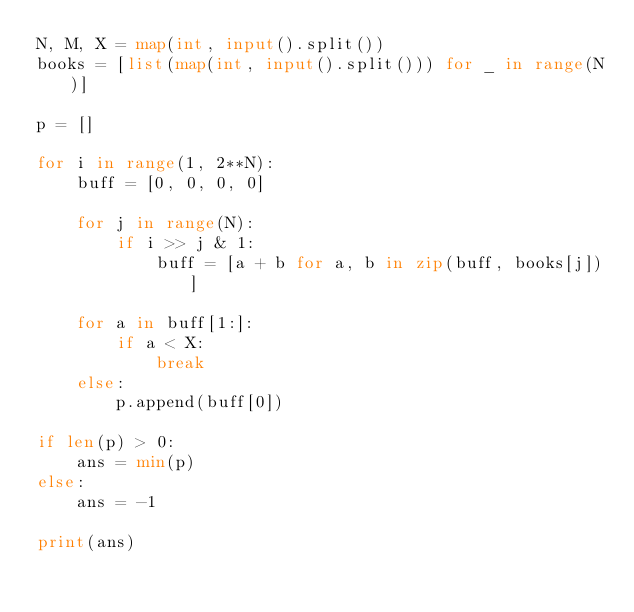Convert code to text. <code><loc_0><loc_0><loc_500><loc_500><_Python_>N, M, X = map(int, input().split())
books = [list(map(int, input().split())) for _ in range(N)]

p = []

for i in range(1, 2**N):
    buff = [0, 0, 0, 0]

    for j in range(N):
        if i >> j & 1:
            buff = [a + b for a, b in zip(buff, books[j])]

    for a in buff[1:]:
        if a < X:
            break
    else:
        p.append(buff[0])

if len(p) > 0:
    ans = min(p)
else:
    ans = -1

print(ans)
</code> 